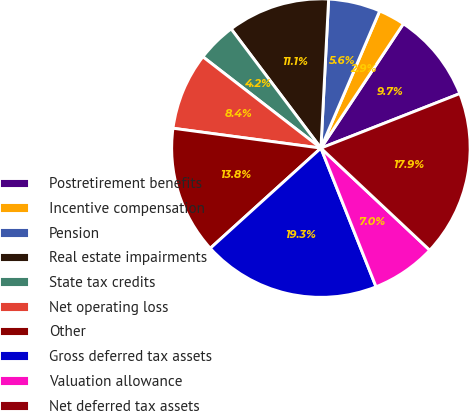<chart> <loc_0><loc_0><loc_500><loc_500><pie_chart><fcel>Postretirement benefits<fcel>Incentive compensation<fcel>Pension<fcel>Real estate impairments<fcel>State tax credits<fcel>Net operating loss<fcel>Other<fcel>Gross deferred tax assets<fcel>Valuation allowance<fcel>Net deferred tax assets<nl><fcel>9.73%<fcel>2.88%<fcel>5.62%<fcel>11.1%<fcel>4.25%<fcel>8.36%<fcel>13.84%<fcel>19.32%<fcel>6.99%<fcel>17.95%<nl></chart> 